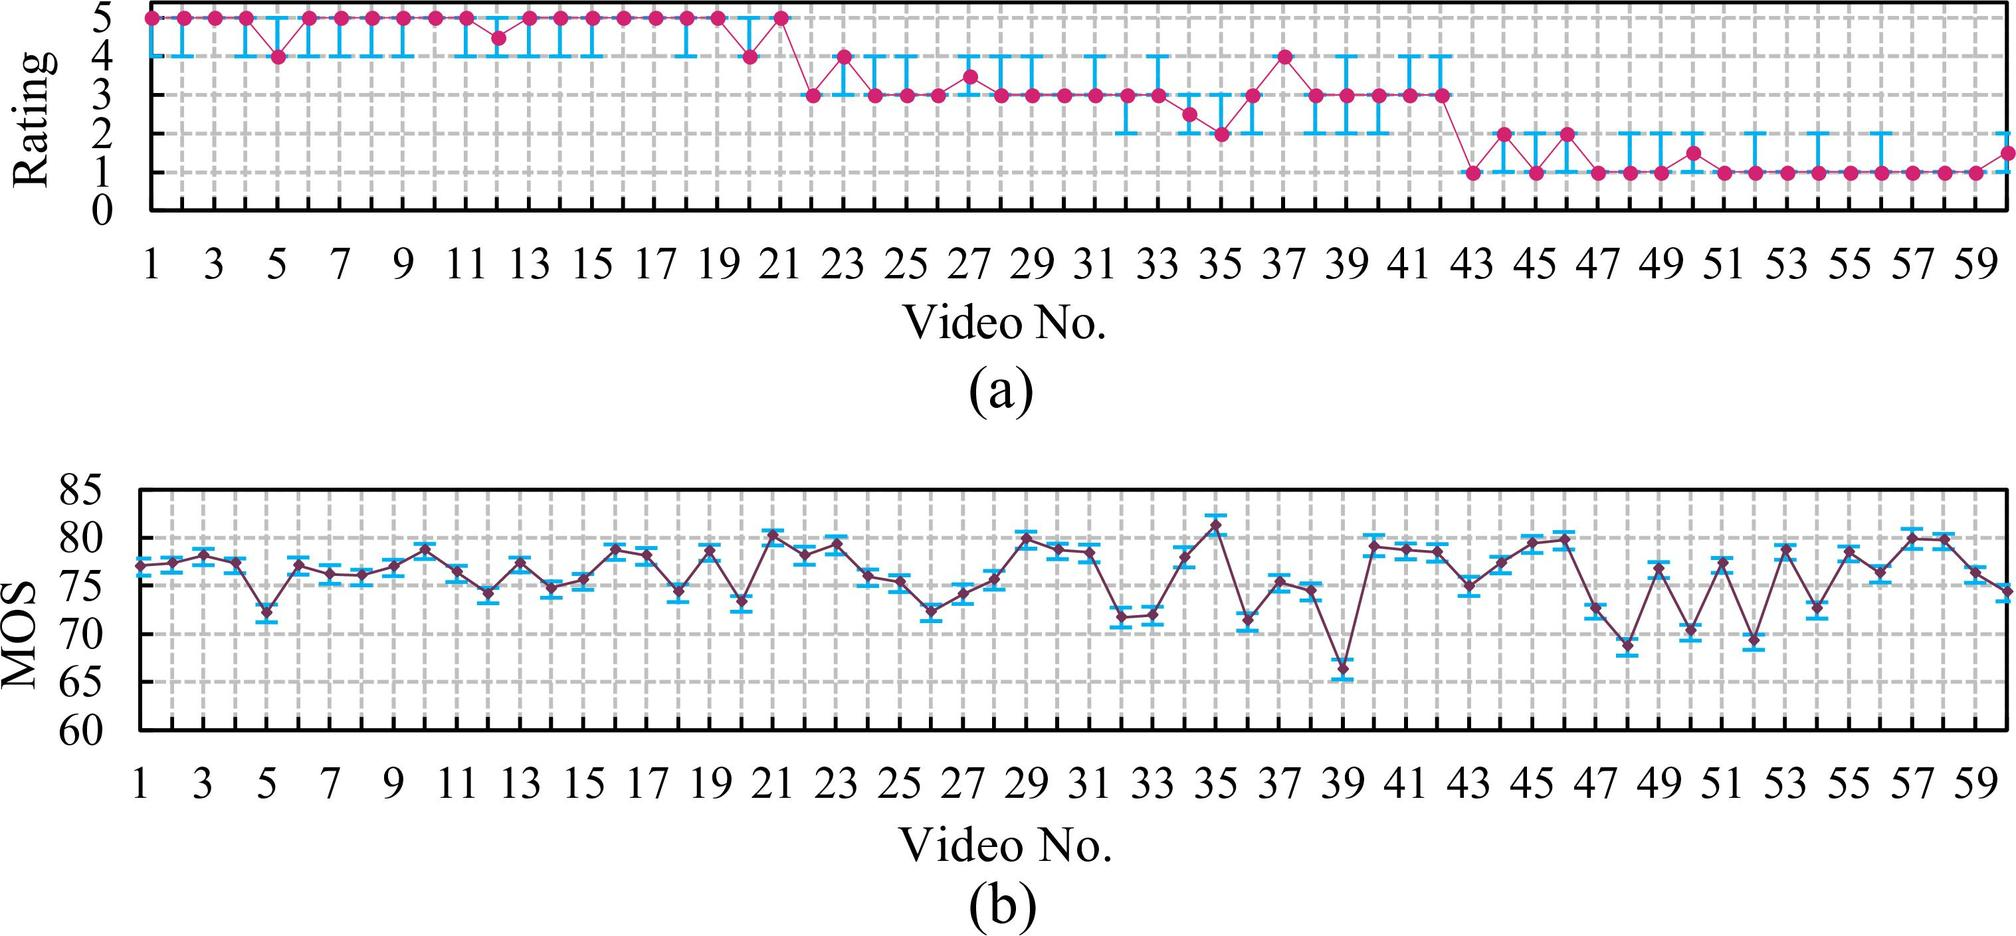What does graph (b) show in relation to graph (a)? Graph (b) seems to represent a separate set of data marked as 'MOS', possibly Mean Opinion Score, which is often used as a subjective measure of video quality. Compared to graph (a), the scores in graph (b) span a broader range and show a different pattern of variation. Correlating the two graphs can provide a more comprehensive understanding of how the video ratings relate to perceived quality and could unveil insights into the consistency of the rating system or the aspects influencing audience judgment.  Can you postulate why MOS scores in graph (b) might show a different pattern than the ratings in graph (a)? One plausible explanation could be that the MOS scores take into account more nuanced aspects of viewer experience, catching subtleties that the simpler rating system of graph (a) might miss. The different pattern may also indicate that the MOS methodology applies a more detailed evaluation framework, possibly involving direct feedback from a group of viewers, while the ratings could be more straightforward and less granular in assessment. 